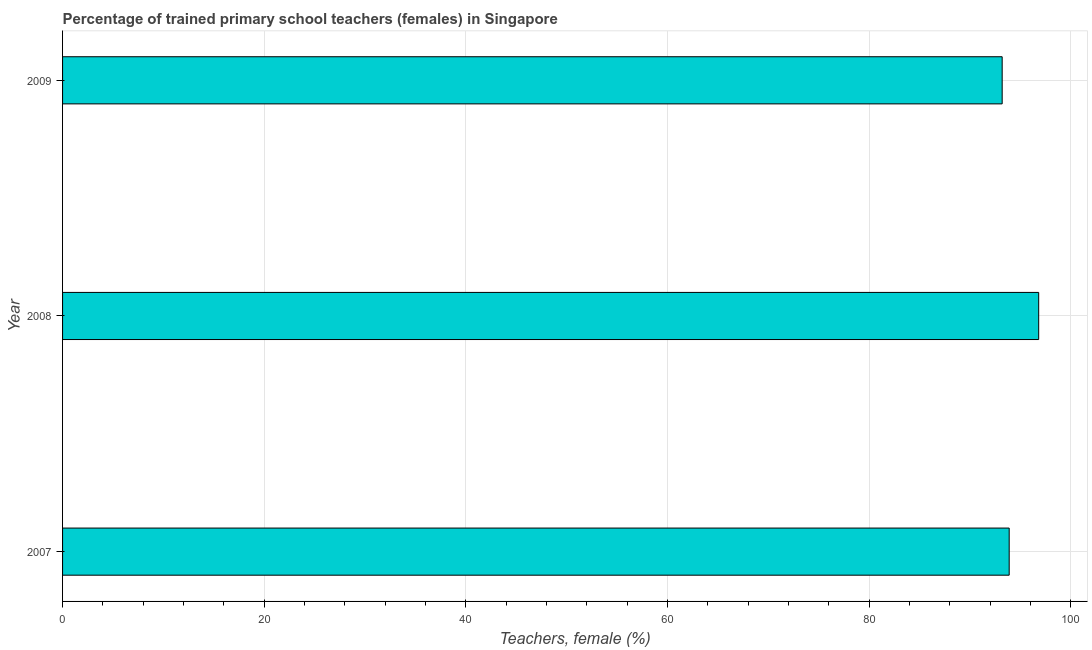What is the title of the graph?
Your answer should be compact. Percentage of trained primary school teachers (females) in Singapore. What is the label or title of the X-axis?
Provide a short and direct response. Teachers, female (%). What is the label or title of the Y-axis?
Your answer should be compact. Year. What is the percentage of trained female teachers in 2008?
Offer a very short reply. 96.81. Across all years, what is the maximum percentage of trained female teachers?
Your response must be concise. 96.81. Across all years, what is the minimum percentage of trained female teachers?
Keep it short and to the point. 93.19. In which year was the percentage of trained female teachers maximum?
Ensure brevity in your answer.  2008. What is the sum of the percentage of trained female teachers?
Your answer should be compact. 283.88. What is the difference between the percentage of trained female teachers in 2007 and 2008?
Provide a succinct answer. -2.93. What is the average percentage of trained female teachers per year?
Make the answer very short. 94.62. What is the median percentage of trained female teachers?
Give a very brief answer. 93.88. In how many years, is the percentage of trained female teachers greater than 36 %?
Provide a short and direct response. 3. What is the ratio of the percentage of trained female teachers in 2007 to that in 2008?
Provide a succinct answer. 0.97. Is the percentage of trained female teachers in 2007 less than that in 2008?
Your answer should be compact. Yes. Is the difference between the percentage of trained female teachers in 2007 and 2008 greater than the difference between any two years?
Keep it short and to the point. No. What is the difference between the highest and the second highest percentage of trained female teachers?
Ensure brevity in your answer.  2.93. What is the difference between the highest and the lowest percentage of trained female teachers?
Provide a succinct answer. 3.62. In how many years, is the percentage of trained female teachers greater than the average percentage of trained female teachers taken over all years?
Offer a very short reply. 1. Are all the bars in the graph horizontal?
Offer a terse response. Yes. What is the difference between two consecutive major ticks on the X-axis?
Provide a succinct answer. 20. What is the Teachers, female (%) of 2007?
Your response must be concise. 93.88. What is the Teachers, female (%) of 2008?
Your answer should be very brief. 96.81. What is the Teachers, female (%) in 2009?
Your answer should be compact. 93.19. What is the difference between the Teachers, female (%) in 2007 and 2008?
Keep it short and to the point. -2.93. What is the difference between the Teachers, female (%) in 2007 and 2009?
Ensure brevity in your answer.  0.7. What is the difference between the Teachers, female (%) in 2008 and 2009?
Your answer should be compact. 3.62. What is the ratio of the Teachers, female (%) in 2007 to that in 2009?
Make the answer very short. 1.01. What is the ratio of the Teachers, female (%) in 2008 to that in 2009?
Provide a short and direct response. 1.04. 